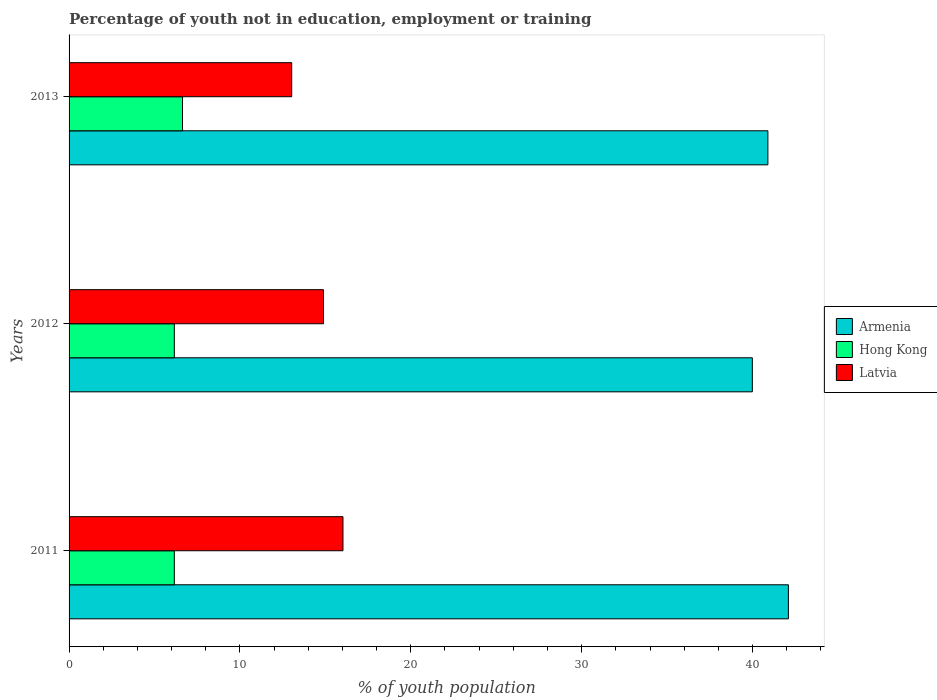How many different coloured bars are there?
Your response must be concise. 3. How many groups of bars are there?
Keep it short and to the point. 3. Are the number of bars on each tick of the Y-axis equal?
Your answer should be very brief. Yes. How many bars are there on the 2nd tick from the bottom?
Give a very brief answer. 3. What is the label of the 2nd group of bars from the top?
Provide a succinct answer. 2012. What is the percentage of unemployed youth population in in Hong Kong in 2012?
Your answer should be very brief. 6.16. Across all years, what is the maximum percentage of unemployed youth population in in Latvia?
Make the answer very short. 16.03. Across all years, what is the minimum percentage of unemployed youth population in in Armenia?
Provide a succinct answer. 39.99. In which year was the percentage of unemployed youth population in in Armenia maximum?
Ensure brevity in your answer.  2011. What is the total percentage of unemployed youth population in in Latvia in the graph?
Give a very brief answer. 43.95. What is the difference between the percentage of unemployed youth population in in Armenia in 2011 and that in 2013?
Provide a succinct answer. 1.2. What is the difference between the percentage of unemployed youth population in in Latvia in 2011 and the percentage of unemployed youth population in in Hong Kong in 2013?
Provide a short and direct response. 9.39. What is the average percentage of unemployed youth population in in Armenia per year?
Keep it short and to the point. 41. In the year 2011, what is the difference between the percentage of unemployed youth population in in Hong Kong and percentage of unemployed youth population in in Latvia?
Provide a succinct answer. -9.87. In how many years, is the percentage of unemployed youth population in in Armenia greater than 6 %?
Give a very brief answer. 3. What is the ratio of the percentage of unemployed youth population in in Armenia in 2011 to that in 2012?
Keep it short and to the point. 1.05. Is the percentage of unemployed youth population in in Latvia in 2011 less than that in 2012?
Make the answer very short. No. What is the difference between the highest and the second highest percentage of unemployed youth population in in Armenia?
Your answer should be compact. 1.2. What is the difference between the highest and the lowest percentage of unemployed youth population in in Armenia?
Your answer should be very brief. 2.11. In how many years, is the percentage of unemployed youth population in in Hong Kong greater than the average percentage of unemployed youth population in in Hong Kong taken over all years?
Keep it short and to the point. 1. What does the 1st bar from the top in 2013 represents?
Keep it short and to the point. Latvia. What does the 2nd bar from the bottom in 2013 represents?
Give a very brief answer. Hong Kong. How many bars are there?
Give a very brief answer. 9. How many years are there in the graph?
Your answer should be very brief. 3. Are the values on the major ticks of X-axis written in scientific E-notation?
Your answer should be compact. No. Does the graph contain any zero values?
Your response must be concise. No. How are the legend labels stacked?
Your answer should be very brief. Vertical. What is the title of the graph?
Offer a very short reply. Percentage of youth not in education, employment or training. What is the label or title of the X-axis?
Ensure brevity in your answer.  % of youth population. What is the % of youth population in Armenia in 2011?
Provide a succinct answer. 42.1. What is the % of youth population in Hong Kong in 2011?
Your answer should be compact. 6.16. What is the % of youth population in Latvia in 2011?
Make the answer very short. 16.03. What is the % of youth population in Armenia in 2012?
Provide a short and direct response. 39.99. What is the % of youth population in Hong Kong in 2012?
Ensure brevity in your answer.  6.16. What is the % of youth population in Latvia in 2012?
Offer a terse response. 14.89. What is the % of youth population in Armenia in 2013?
Provide a short and direct response. 40.9. What is the % of youth population in Hong Kong in 2013?
Offer a very short reply. 6.64. What is the % of youth population in Latvia in 2013?
Keep it short and to the point. 13.03. Across all years, what is the maximum % of youth population of Armenia?
Ensure brevity in your answer.  42.1. Across all years, what is the maximum % of youth population in Hong Kong?
Your answer should be very brief. 6.64. Across all years, what is the maximum % of youth population of Latvia?
Your answer should be compact. 16.03. Across all years, what is the minimum % of youth population in Armenia?
Make the answer very short. 39.99. Across all years, what is the minimum % of youth population in Hong Kong?
Make the answer very short. 6.16. Across all years, what is the minimum % of youth population of Latvia?
Offer a very short reply. 13.03. What is the total % of youth population in Armenia in the graph?
Your response must be concise. 122.99. What is the total % of youth population of Hong Kong in the graph?
Give a very brief answer. 18.96. What is the total % of youth population of Latvia in the graph?
Provide a short and direct response. 43.95. What is the difference between the % of youth population in Armenia in 2011 and that in 2012?
Make the answer very short. 2.11. What is the difference between the % of youth population in Latvia in 2011 and that in 2012?
Provide a succinct answer. 1.14. What is the difference between the % of youth population of Armenia in 2011 and that in 2013?
Your answer should be very brief. 1.2. What is the difference between the % of youth population of Hong Kong in 2011 and that in 2013?
Offer a terse response. -0.48. What is the difference between the % of youth population in Armenia in 2012 and that in 2013?
Offer a terse response. -0.91. What is the difference between the % of youth population of Hong Kong in 2012 and that in 2013?
Give a very brief answer. -0.48. What is the difference between the % of youth population of Latvia in 2012 and that in 2013?
Keep it short and to the point. 1.86. What is the difference between the % of youth population of Armenia in 2011 and the % of youth population of Hong Kong in 2012?
Keep it short and to the point. 35.94. What is the difference between the % of youth population in Armenia in 2011 and the % of youth population in Latvia in 2012?
Ensure brevity in your answer.  27.21. What is the difference between the % of youth population of Hong Kong in 2011 and the % of youth population of Latvia in 2012?
Your response must be concise. -8.73. What is the difference between the % of youth population in Armenia in 2011 and the % of youth population in Hong Kong in 2013?
Your answer should be compact. 35.46. What is the difference between the % of youth population in Armenia in 2011 and the % of youth population in Latvia in 2013?
Ensure brevity in your answer.  29.07. What is the difference between the % of youth population of Hong Kong in 2011 and the % of youth population of Latvia in 2013?
Your response must be concise. -6.87. What is the difference between the % of youth population in Armenia in 2012 and the % of youth population in Hong Kong in 2013?
Offer a very short reply. 33.35. What is the difference between the % of youth population of Armenia in 2012 and the % of youth population of Latvia in 2013?
Keep it short and to the point. 26.96. What is the difference between the % of youth population of Hong Kong in 2012 and the % of youth population of Latvia in 2013?
Make the answer very short. -6.87. What is the average % of youth population of Armenia per year?
Offer a terse response. 41. What is the average % of youth population of Hong Kong per year?
Provide a short and direct response. 6.32. What is the average % of youth population in Latvia per year?
Ensure brevity in your answer.  14.65. In the year 2011, what is the difference between the % of youth population of Armenia and % of youth population of Hong Kong?
Provide a succinct answer. 35.94. In the year 2011, what is the difference between the % of youth population of Armenia and % of youth population of Latvia?
Offer a very short reply. 26.07. In the year 2011, what is the difference between the % of youth population in Hong Kong and % of youth population in Latvia?
Your response must be concise. -9.87. In the year 2012, what is the difference between the % of youth population of Armenia and % of youth population of Hong Kong?
Make the answer very short. 33.83. In the year 2012, what is the difference between the % of youth population in Armenia and % of youth population in Latvia?
Offer a terse response. 25.1. In the year 2012, what is the difference between the % of youth population of Hong Kong and % of youth population of Latvia?
Your answer should be compact. -8.73. In the year 2013, what is the difference between the % of youth population in Armenia and % of youth population in Hong Kong?
Offer a very short reply. 34.26. In the year 2013, what is the difference between the % of youth population of Armenia and % of youth population of Latvia?
Give a very brief answer. 27.87. In the year 2013, what is the difference between the % of youth population in Hong Kong and % of youth population in Latvia?
Give a very brief answer. -6.39. What is the ratio of the % of youth population of Armenia in 2011 to that in 2012?
Keep it short and to the point. 1.05. What is the ratio of the % of youth population in Latvia in 2011 to that in 2012?
Provide a succinct answer. 1.08. What is the ratio of the % of youth population of Armenia in 2011 to that in 2013?
Offer a very short reply. 1.03. What is the ratio of the % of youth population in Hong Kong in 2011 to that in 2013?
Your answer should be very brief. 0.93. What is the ratio of the % of youth population in Latvia in 2011 to that in 2013?
Provide a short and direct response. 1.23. What is the ratio of the % of youth population in Armenia in 2012 to that in 2013?
Give a very brief answer. 0.98. What is the ratio of the % of youth population in Hong Kong in 2012 to that in 2013?
Offer a terse response. 0.93. What is the ratio of the % of youth population in Latvia in 2012 to that in 2013?
Your response must be concise. 1.14. What is the difference between the highest and the second highest % of youth population in Hong Kong?
Offer a very short reply. 0.48. What is the difference between the highest and the second highest % of youth population in Latvia?
Provide a succinct answer. 1.14. What is the difference between the highest and the lowest % of youth population in Armenia?
Provide a short and direct response. 2.11. What is the difference between the highest and the lowest % of youth population in Hong Kong?
Ensure brevity in your answer.  0.48. 